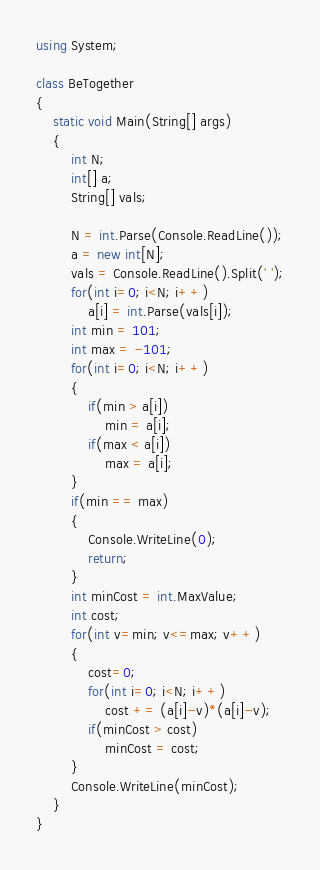<code> <loc_0><loc_0><loc_500><loc_500><_C#_>using System;

class BeTogether
{
	static void Main(String[] args)
	{
		int N;
		int[] a;
		String[] vals;

		N = int.Parse(Console.ReadLine());
		a = new int[N];
		vals = Console.ReadLine().Split(' ');
		for(int i=0; i<N; i++)
			a[i] = int.Parse(vals[i]);
		int min = 101;
		int max = -101;
		for(int i=0; i<N; i++)
		{
			if(min > a[i])
				min = a[i];
			if(max < a[i])
				max = a[i];
		}
		if(min == max)
		{
			Console.WriteLine(0);
			return;
		}
		int minCost = int.MaxValue;
		int cost;
		for(int v=min; v<=max; v++)
		{
			cost=0;
			for(int i=0; i<N; i++)
				cost += (a[i]-v)*(a[i]-v);
			if(minCost > cost)
				minCost = cost;
		}
		Console.WriteLine(minCost);
	}
}
</code> 